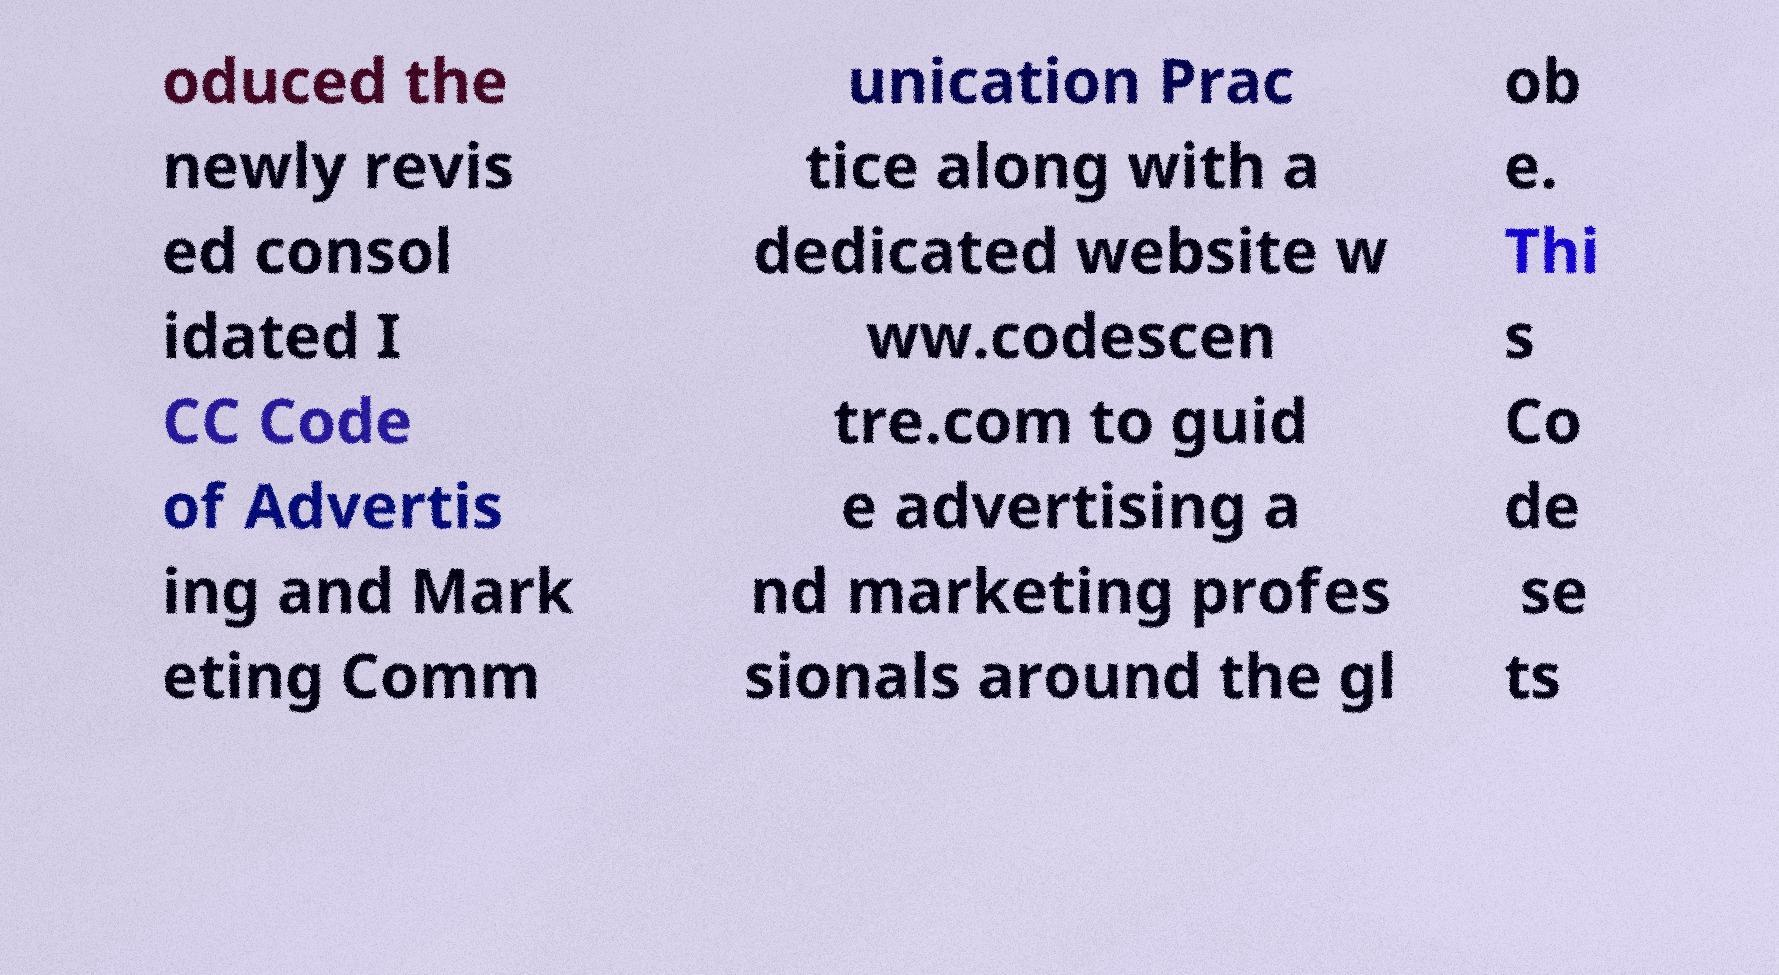Could you assist in decoding the text presented in this image and type it out clearly? oduced the newly revis ed consol idated I CC Code of Advertis ing and Mark eting Comm unication Prac tice along with a dedicated website w ww.codescen tre.com to guid e advertising a nd marketing profes sionals around the gl ob e. Thi s Co de se ts 